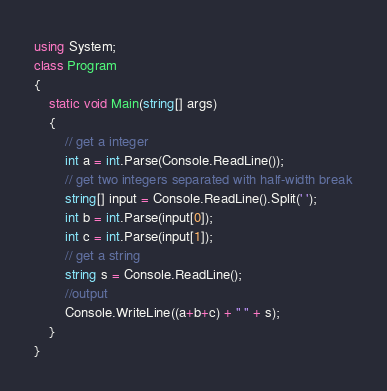Convert code to text. <code><loc_0><loc_0><loc_500><loc_500><_C#_>using System;
class Program
{
	static void Main(string[] args)
	{
		// get a integer
		int a = int.Parse(Console.ReadLine());
		// get two integers separated with half-width break
		string[] input = Console.ReadLine().Split(' ');
		int b = int.Parse(input[0]);
		int c = int.Parse(input[1]);
		// get a string
		string s = Console.ReadLine();
		//output
		Console.WriteLine((a+b+c) + " " + s);
	}
}</code> 